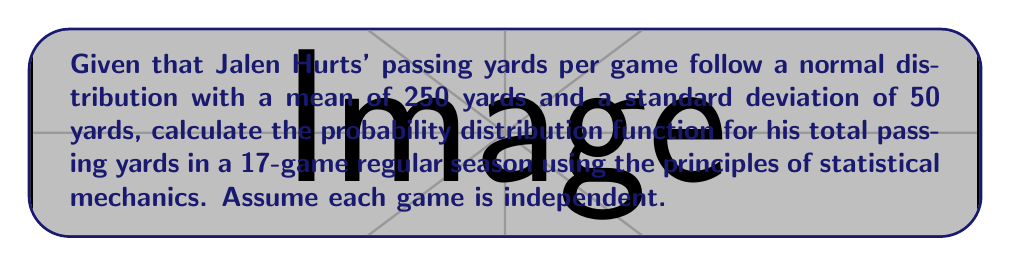Can you answer this question? To solve this problem, we'll use concepts from statistical mechanics and probability theory:

1. First, we recognize that the total passing yards for the season is the sum of independent, normally distributed random variables (one for each game).

2. The Central Limit Theorem states that the sum of independent, identically distributed random variables approaches a normal distribution, regardless of the underlying distribution.

3. For a normal distribution, when we sum n independent variables, the mean and variance of the sum are:

   $\mu_{sum} = n\mu$
   $\sigma^2_{sum} = n\sigma^2$

4. In this case:
   n = 17 (games in a season)
   $\mu = 250$ yards (mean per game)
   $\sigma = 50$ yards (standard deviation per game)

5. Calculate the mean for the season:
   $\mu_{season} = 17 \times 250 = 4250$ yards

6. Calculate the variance for the season:
   $\sigma^2_{season} = 17 \times 50^2 = 42500$ sq yards

7. Calculate the standard deviation for the season:
   $\sigma_{season} = \sqrt{42500} \approx 206.16$ yards

8. The probability distribution function for a normal distribution is:

   $$f(x) = \frac{1}{\sigma\sqrt{2\pi}} e^{-\frac{(x-\mu)^2}{2\sigma^2}}$$

9. Substituting our values:

   $$f(x) = \frac{1}{206.16\sqrt{2\pi}} e^{-\frac{(x-4250)^2}{2(206.16)^2}}$$

Where x represents the total passing yards for the season.
Answer: $$f(x) = \frac{1}{206.16\sqrt{2\pi}} e^{-\frac{(x-4250)^2}{2(206.16)^2}}$$ 